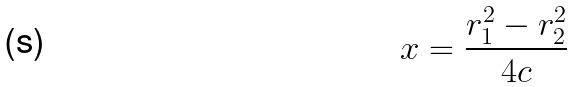<formula> <loc_0><loc_0><loc_500><loc_500>x = \frac { r _ { 1 } ^ { 2 } - r _ { 2 } ^ { 2 } } { 4 c }</formula> 